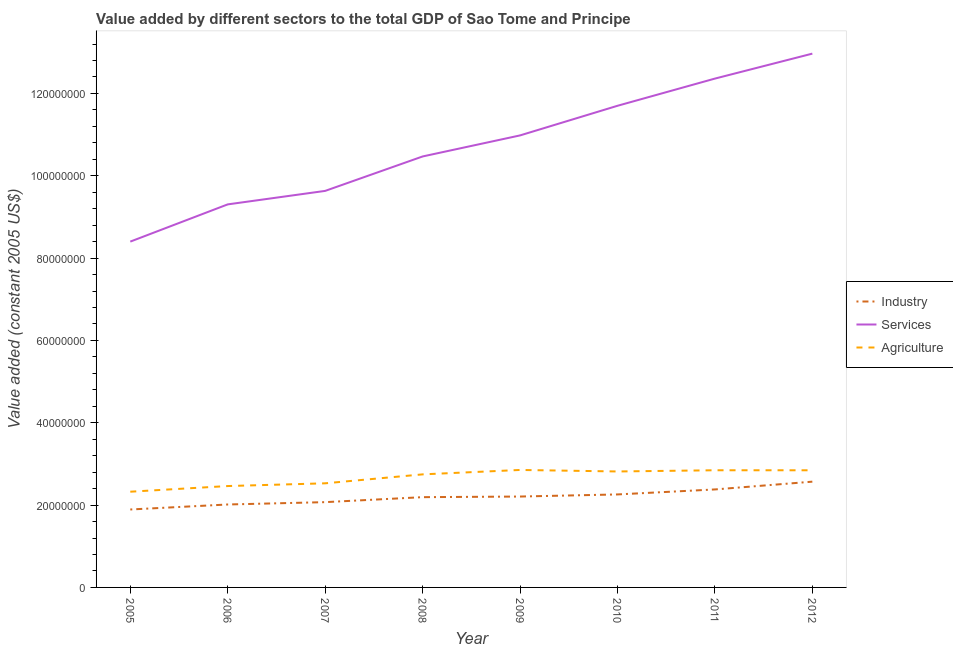How many different coloured lines are there?
Make the answer very short. 3. What is the value added by industrial sector in 2006?
Give a very brief answer. 2.01e+07. Across all years, what is the maximum value added by services?
Give a very brief answer. 1.30e+08. Across all years, what is the minimum value added by industrial sector?
Offer a terse response. 1.89e+07. In which year was the value added by services minimum?
Offer a terse response. 2005. What is the total value added by services in the graph?
Your answer should be compact. 8.58e+08. What is the difference between the value added by services in 2010 and that in 2012?
Give a very brief answer. -1.27e+07. What is the difference between the value added by services in 2012 and the value added by agricultural sector in 2006?
Offer a terse response. 1.05e+08. What is the average value added by agricultural sector per year?
Your response must be concise. 2.68e+07. In the year 2012, what is the difference between the value added by services and value added by industrial sector?
Your response must be concise. 1.04e+08. In how many years, is the value added by industrial sector greater than 24000000 US$?
Your answer should be very brief. 1. What is the ratio of the value added by industrial sector in 2005 to that in 2006?
Ensure brevity in your answer.  0.94. Is the value added by agricultural sector in 2009 less than that in 2011?
Provide a succinct answer. No. Is the difference between the value added by industrial sector in 2005 and 2010 greater than the difference between the value added by services in 2005 and 2010?
Ensure brevity in your answer.  Yes. What is the difference between the highest and the second highest value added by agricultural sector?
Provide a succinct answer. 7.39e+04. What is the difference between the highest and the lowest value added by agricultural sector?
Your answer should be compact. 5.28e+06. In how many years, is the value added by agricultural sector greater than the average value added by agricultural sector taken over all years?
Keep it short and to the point. 5. Does the value added by agricultural sector monotonically increase over the years?
Make the answer very short. No. Is the value added by industrial sector strictly greater than the value added by services over the years?
Your answer should be compact. No. How many lines are there?
Make the answer very short. 3. How many years are there in the graph?
Your response must be concise. 8. What is the difference between two consecutive major ticks on the Y-axis?
Keep it short and to the point. 2.00e+07. Are the values on the major ticks of Y-axis written in scientific E-notation?
Keep it short and to the point. No. Does the graph contain any zero values?
Make the answer very short. No. Where does the legend appear in the graph?
Provide a succinct answer. Center right. What is the title of the graph?
Offer a terse response. Value added by different sectors to the total GDP of Sao Tome and Principe. What is the label or title of the Y-axis?
Give a very brief answer. Value added (constant 2005 US$). What is the Value added (constant 2005 US$) of Industry in 2005?
Provide a short and direct response. 1.89e+07. What is the Value added (constant 2005 US$) of Services in 2005?
Offer a terse response. 8.40e+07. What is the Value added (constant 2005 US$) in Agriculture in 2005?
Give a very brief answer. 2.33e+07. What is the Value added (constant 2005 US$) in Industry in 2006?
Offer a terse response. 2.01e+07. What is the Value added (constant 2005 US$) in Services in 2006?
Your answer should be very brief. 9.31e+07. What is the Value added (constant 2005 US$) in Agriculture in 2006?
Offer a very short reply. 2.46e+07. What is the Value added (constant 2005 US$) of Industry in 2007?
Offer a terse response. 2.07e+07. What is the Value added (constant 2005 US$) in Services in 2007?
Provide a succinct answer. 9.63e+07. What is the Value added (constant 2005 US$) in Agriculture in 2007?
Ensure brevity in your answer.  2.53e+07. What is the Value added (constant 2005 US$) in Industry in 2008?
Give a very brief answer. 2.19e+07. What is the Value added (constant 2005 US$) in Services in 2008?
Offer a terse response. 1.05e+08. What is the Value added (constant 2005 US$) in Agriculture in 2008?
Offer a terse response. 2.75e+07. What is the Value added (constant 2005 US$) in Industry in 2009?
Your response must be concise. 2.21e+07. What is the Value added (constant 2005 US$) in Services in 2009?
Give a very brief answer. 1.10e+08. What is the Value added (constant 2005 US$) of Agriculture in 2009?
Offer a very short reply. 2.85e+07. What is the Value added (constant 2005 US$) in Industry in 2010?
Your answer should be compact. 2.26e+07. What is the Value added (constant 2005 US$) in Services in 2010?
Give a very brief answer. 1.17e+08. What is the Value added (constant 2005 US$) of Agriculture in 2010?
Provide a short and direct response. 2.82e+07. What is the Value added (constant 2005 US$) in Industry in 2011?
Keep it short and to the point. 2.38e+07. What is the Value added (constant 2005 US$) of Services in 2011?
Make the answer very short. 1.24e+08. What is the Value added (constant 2005 US$) of Agriculture in 2011?
Your answer should be very brief. 2.85e+07. What is the Value added (constant 2005 US$) in Industry in 2012?
Make the answer very short. 2.57e+07. What is the Value added (constant 2005 US$) of Services in 2012?
Your answer should be very brief. 1.30e+08. What is the Value added (constant 2005 US$) in Agriculture in 2012?
Your response must be concise. 2.85e+07. Across all years, what is the maximum Value added (constant 2005 US$) in Industry?
Offer a very short reply. 2.57e+07. Across all years, what is the maximum Value added (constant 2005 US$) of Services?
Keep it short and to the point. 1.30e+08. Across all years, what is the maximum Value added (constant 2005 US$) of Agriculture?
Ensure brevity in your answer.  2.85e+07. Across all years, what is the minimum Value added (constant 2005 US$) of Industry?
Provide a short and direct response. 1.89e+07. Across all years, what is the minimum Value added (constant 2005 US$) of Services?
Your answer should be very brief. 8.40e+07. Across all years, what is the minimum Value added (constant 2005 US$) of Agriculture?
Provide a short and direct response. 2.33e+07. What is the total Value added (constant 2005 US$) of Industry in the graph?
Make the answer very short. 1.76e+08. What is the total Value added (constant 2005 US$) in Services in the graph?
Your answer should be very brief. 8.58e+08. What is the total Value added (constant 2005 US$) of Agriculture in the graph?
Offer a very short reply. 2.14e+08. What is the difference between the Value added (constant 2005 US$) of Industry in 2005 and that in 2006?
Provide a succinct answer. -1.22e+06. What is the difference between the Value added (constant 2005 US$) of Services in 2005 and that in 2006?
Ensure brevity in your answer.  -9.04e+06. What is the difference between the Value added (constant 2005 US$) in Agriculture in 2005 and that in 2006?
Provide a succinct answer. -1.38e+06. What is the difference between the Value added (constant 2005 US$) in Industry in 2005 and that in 2007?
Your answer should be very brief. -1.78e+06. What is the difference between the Value added (constant 2005 US$) of Services in 2005 and that in 2007?
Offer a terse response. -1.23e+07. What is the difference between the Value added (constant 2005 US$) in Agriculture in 2005 and that in 2007?
Provide a succinct answer. -2.04e+06. What is the difference between the Value added (constant 2005 US$) in Industry in 2005 and that in 2008?
Offer a very short reply. -2.99e+06. What is the difference between the Value added (constant 2005 US$) in Services in 2005 and that in 2008?
Your response must be concise. -2.07e+07. What is the difference between the Value added (constant 2005 US$) of Agriculture in 2005 and that in 2008?
Your response must be concise. -4.21e+06. What is the difference between the Value added (constant 2005 US$) in Industry in 2005 and that in 2009?
Offer a very short reply. -3.15e+06. What is the difference between the Value added (constant 2005 US$) of Services in 2005 and that in 2009?
Ensure brevity in your answer.  -2.58e+07. What is the difference between the Value added (constant 2005 US$) of Agriculture in 2005 and that in 2009?
Your answer should be compact. -5.28e+06. What is the difference between the Value added (constant 2005 US$) in Industry in 2005 and that in 2010?
Offer a terse response. -3.66e+06. What is the difference between the Value added (constant 2005 US$) of Services in 2005 and that in 2010?
Ensure brevity in your answer.  -3.30e+07. What is the difference between the Value added (constant 2005 US$) in Agriculture in 2005 and that in 2010?
Keep it short and to the point. -4.92e+06. What is the difference between the Value added (constant 2005 US$) of Industry in 2005 and that in 2011?
Keep it short and to the point. -4.87e+06. What is the difference between the Value added (constant 2005 US$) of Services in 2005 and that in 2011?
Ensure brevity in your answer.  -3.96e+07. What is the difference between the Value added (constant 2005 US$) in Agriculture in 2005 and that in 2011?
Make the answer very short. -5.21e+06. What is the difference between the Value added (constant 2005 US$) in Industry in 2005 and that in 2012?
Ensure brevity in your answer.  -6.76e+06. What is the difference between the Value added (constant 2005 US$) in Services in 2005 and that in 2012?
Give a very brief answer. -4.57e+07. What is the difference between the Value added (constant 2005 US$) of Agriculture in 2005 and that in 2012?
Make the answer very short. -5.20e+06. What is the difference between the Value added (constant 2005 US$) in Industry in 2006 and that in 2007?
Your answer should be very brief. -5.69e+05. What is the difference between the Value added (constant 2005 US$) of Services in 2006 and that in 2007?
Offer a terse response. -3.28e+06. What is the difference between the Value added (constant 2005 US$) in Agriculture in 2006 and that in 2007?
Offer a very short reply. -6.63e+05. What is the difference between the Value added (constant 2005 US$) of Industry in 2006 and that in 2008?
Offer a terse response. -1.78e+06. What is the difference between the Value added (constant 2005 US$) of Services in 2006 and that in 2008?
Provide a short and direct response. -1.16e+07. What is the difference between the Value added (constant 2005 US$) in Agriculture in 2006 and that in 2008?
Your response must be concise. -2.84e+06. What is the difference between the Value added (constant 2005 US$) of Industry in 2006 and that in 2009?
Provide a short and direct response. -1.93e+06. What is the difference between the Value added (constant 2005 US$) of Services in 2006 and that in 2009?
Make the answer very short. -1.68e+07. What is the difference between the Value added (constant 2005 US$) of Agriculture in 2006 and that in 2009?
Provide a succinct answer. -3.91e+06. What is the difference between the Value added (constant 2005 US$) in Industry in 2006 and that in 2010?
Your answer should be very brief. -2.44e+06. What is the difference between the Value added (constant 2005 US$) in Services in 2006 and that in 2010?
Your answer should be compact. -2.40e+07. What is the difference between the Value added (constant 2005 US$) in Agriculture in 2006 and that in 2010?
Keep it short and to the point. -3.54e+06. What is the difference between the Value added (constant 2005 US$) in Industry in 2006 and that in 2011?
Your response must be concise. -3.65e+06. What is the difference between the Value added (constant 2005 US$) in Services in 2006 and that in 2011?
Your answer should be very brief. -3.06e+07. What is the difference between the Value added (constant 2005 US$) in Agriculture in 2006 and that in 2011?
Make the answer very short. -3.83e+06. What is the difference between the Value added (constant 2005 US$) of Industry in 2006 and that in 2012?
Your answer should be compact. -5.55e+06. What is the difference between the Value added (constant 2005 US$) of Services in 2006 and that in 2012?
Your answer should be very brief. -3.66e+07. What is the difference between the Value added (constant 2005 US$) in Agriculture in 2006 and that in 2012?
Your response must be concise. -3.83e+06. What is the difference between the Value added (constant 2005 US$) in Industry in 2007 and that in 2008?
Provide a succinct answer. -1.21e+06. What is the difference between the Value added (constant 2005 US$) in Services in 2007 and that in 2008?
Ensure brevity in your answer.  -8.36e+06. What is the difference between the Value added (constant 2005 US$) of Agriculture in 2007 and that in 2008?
Give a very brief answer. -2.17e+06. What is the difference between the Value added (constant 2005 US$) in Industry in 2007 and that in 2009?
Your answer should be compact. -1.36e+06. What is the difference between the Value added (constant 2005 US$) of Services in 2007 and that in 2009?
Keep it short and to the point. -1.35e+07. What is the difference between the Value added (constant 2005 US$) in Agriculture in 2007 and that in 2009?
Make the answer very short. -3.25e+06. What is the difference between the Value added (constant 2005 US$) of Industry in 2007 and that in 2010?
Your answer should be compact. -1.87e+06. What is the difference between the Value added (constant 2005 US$) of Services in 2007 and that in 2010?
Your response must be concise. -2.07e+07. What is the difference between the Value added (constant 2005 US$) in Agriculture in 2007 and that in 2010?
Give a very brief answer. -2.88e+06. What is the difference between the Value added (constant 2005 US$) of Industry in 2007 and that in 2011?
Your response must be concise. -3.09e+06. What is the difference between the Value added (constant 2005 US$) of Services in 2007 and that in 2011?
Provide a short and direct response. -2.73e+07. What is the difference between the Value added (constant 2005 US$) of Agriculture in 2007 and that in 2011?
Offer a very short reply. -3.17e+06. What is the difference between the Value added (constant 2005 US$) in Industry in 2007 and that in 2012?
Keep it short and to the point. -4.98e+06. What is the difference between the Value added (constant 2005 US$) in Services in 2007 and that in 2012?
Offer a terse response. -3.33e+07. What is the difference between the Value added (constant 2005 US$) in Agriculture in 2007 and that in 2012?
Provide a short and direct response. -3.17e+06. What is the difference between the Value added (constant 2005 US$) of Industry in 2008 and that in 2009?
Your answer should be very brief. -1.52e+05. What is the difference between the Value added (constant 2005 US$) in Services in 2008 and that in 2009?
Provide a succinct answer. -5.11e+06. What is the difference between the Value added (constant 2005 US$) in Agriculture in 2008 and that in 2009?
Your answer should be very brief. -1.07e+06. What is the difference between the Value added (constant 2005 US$) of Industry in 2008 and that in 2010?
Offer a very short reply. -6.63e+05. What is the difference between the Value added (constant 2005 US$) in Services in 2008 and that in 2010?
Your answer should be compact. -1.23e+07. What is the difference between the Value added (constant 2005 US$) of Agriculture in 2008 and that in 2010?
Offer a very short reply. -7.05e+05. What is the difference between the Value added (constant 2005 US$) of Industry in 2008 and that in 2011?
Keep it short and to the point. -1.88e+06. What is the difference between the Value added (constant 2005 US$) of Services in 2008 and that in 2011?
Offer a very short reply. -1.89e+07. What is the difference between the Value added (constant 2005 US$) in Agriculture in 2008 and that in 2011?
Ensure brevity in your answer.  -9.98e+05. What is the difference between the Value added (constant 2005 US$) of Industry in 2008 and that in 2012?
Offer a terse response. -3.77e+06. What is the difference between the Value added (constant 2005 US$) in Services in 2008 and that in 2012?
Your answer should be compact. -2.50e+07. What is the difference between the Value added (constant 2005 US$) of Agriculture in 2008 and that in 2012?
Provide a succinct answer. -9.93e+05. What is the difference between the Value added (constant 2005 US$) of Industry in 2009 and that in 2010?
Your answer should be very brief. -5.12e+05. What is the difference between the Value added (constant 2005 US$) in Services in 2009 and that in 2010?
Your response must be concise. -7.20e+06. What is the difference between the Value added (constant 2005 US$) of Agriculture in 2009 and that in 2010?
Your answer should be very brief. 3.67e+05. What is the difference between the Value added (constant 2005 US$) in Industry in 2009 and that in 2011?
Provide a short and direct response. -1.72e+06. What is the difference between the Value added (constant 2005 US$) in Services in 2009 and that in 2011?
Offer a terse response. -1.38e+07. What is the difference between the Value added (constant 2005 US$) in Agriculture in 2009 and that in 2011?
Your answer should be very brief. 7.39e+04. What is the difference between the Value added (constant 2005 US$) of Industry in 2009 and that in 2012?
Provide a succinct answer. -3.61e+06. What is the difference between the Value added (constant 2005 US$) of Services in 2009 and that in 2012?
Provide a short and direct response. -1.99e+07. What is the difference between the Value added (constant 2005 US$) in Agriculture in 2009 and that in 2012?
Your answer should be compact. 7.86e+04. What is the difference between the Value added (constant 2005 US$) of Industry in 2010 and that in 2011?
Provide a succinct answer. -1.21e+06. What is the difference between the Value added (constant 2005 US$) of Services in 2010 and that in 2011?
Your answer should be very brief. -6.61e+06. What is the difference between the Value added (constant 2005 US$) in Agriculture in 2010 and that in 2011?
Your response must be concise. -2.93e+05. What is the difference between the Value added (constant 2005 US$) of Industry in 2010 and that in 2012?
Offer a terse response. -3.10e+06. What is the difference between the Value added (constant 2005 US$) in Services in 2010 and that in 2012?
Ensure brevity in your answer.  -1.27e+07. What is the difference between the Value added (constant 2005 US$) in Agriculture in 2010 and that in 2012?
Your response must be concise. -2.89e+05. What is the difference between the Value added (constant 2005 US$) in Industry in 2011 and that in 2012?
Provide a short and direct response. -1.89e+06. What is the difference between the Value added (constant 2005 US$) in Services in 2011 and that in 2012?
Provide a succinct answer. -6.07e+06. What is the difference between the Value added (constant 2005 US$) of Agriculture in 2011 and that in 2012?
Your response must be concise. 4665.81. What is the difference between the Value added (constant 2005 US$) in Industry in 2005 and the Value added (constant 2005 US$) in Services in 2006?
Your response must be concise. -7.41e+07. What is the difference between the Value added (constant 2005 US$) of Industry in 2005 and the Value added (constant 2005 US$) of Agriculture in 2006?
Keep it short and to the point. -5.70e+06. What is the difference between the Value added (constant 2005 US$) in Services in 2005 and the Value added (constant 2005 US$) in Agriculture in 2006?
Provide a succinct answer. 5.94e+07. What is the difference between the Value added (constant 2005 US$) of Industry in 2005 and the Value added (constant 2005 US$) of Services in 2007?
Offer a terse response. -7.74e+07. What is the difference between the Value added (constant 2005 US$) in Industry in 2005 and the Value added (constant 2005 US$) in Agriculture in 2007?
Offer a very short reply. -6.36e+06. What is the difference between the Value added (constant 2005 US$) in Services in 2005 and the Value added (constant 2005 US$) in Agriculture in 2007?
Ensure brevity in your answer.  5.87e+07. What is the difference between the Value added (constant 2005 US$) of Industry in 2005 and the Value added (constant 2005 US$) of Services in 2008?
Keep it short and to the point. -8.58e+07. What is the difference between the Value added (constant 2005 US$) of Industry in 2005 and the Value added (constant 2005 US$) of Agriculture in 2008?
Offer a terse response. -8.53e+06. What is the difference between the Value added (constant 2005 US$) of Services in 2005 and the Value added (constant 2005 US$) of Agriculture in 2008?
Give a very brief answer. 5.65e+07. What is the difference between the Value added (constant 2005 US$) in Industry in 2005 and the Value added (constant 2005 US$) in Services in 2009?
Your answer should be very brief. -9.09e+07. What is the difference between the Value added (constant 2005 US$) in Industry in 2005 and the Value added (constant 2005 US$) in Agriculture in 2009?
Provide a short and direct response. -9.60e+06. What is the difference between the Value added (constant 2005 US$) in Services in 2005 and the Value added (constant 2005 US$) in Agriculture in 2009?
Provide a succinct answer. 5.55e+07. What is the difference between the Value added (constant 2005 US$) in Industry in 2005 and the Value added (constant 2005 US$) in Services in 2010?
Ensure brevity in your answer.  -9.81e+07. What is the difference between the Value added (constant 2005 US$) of Industry in 2005 and the Value added (constant 2005 US$) of Agriculture in 2010?
Your answer should be very brief. -9.24e+06. What is the difference between the Value added (constant 2005 US$) in Services in 2005 and the Value added (constant 2005 US$) in Agriculture in 2010?
Your answer should be compact. 5.58e+07. What is the difference between the Value added (constant 2005 US$) in Industry in 2005 and the Value added (constant 2005 US$) in Services in 2011?
Keep it short and to the point. -1.05e+08. What is the difference between the Value added (constant 2005 US$) in Industry in 2005 and the Value added (constant 2005 US$) in Agriculture in 2011?
Give a very brief answer. -9.53e+06. What is the difference between the Value added (constant 2005 US$) of Services in 2005 and the Value added (constant 2005 US$) of Agriculture in 2011?
Your response must be concise. 5.55e+07. What is the difference between the Value added (constant 2005 US$) of Industry in 2005 and the Value added (constant 2005 US$) of Services in 2012?
Give a very brief answer. -1.11e+08. What is the difference between the Value added (constant 2005 US$) of Industry in 2005 and the Value added (constant 2005 US$) of Agriculture in 2012?
Your answer should be compact. -9.53e+06. What is the difference between the Value added (constant 2005 US$) in Services in 2005 and the Value added (constant 2005 US$) in Agriculture in 2012?
Your answer should be very brief. 5.55e+07. What is the difference between the Value added (constant 2005 US$) of Industry in 2006 and the Value added (constant 2005 US$) of Services in 2007?
Give a very brief answer. -7.62e+07. What is the difference between the Value added (constant 2005 US$) in Industry in 2006 and the Value added (constant 2005 US$) in Agriculture in 2007?
Make the answer very short. -5.14e+06. What is the difference between the Value added (constant 2005 US$) in Services in 2006 and the Value added (constant 2005 US$) in Agriculture in 2007?
Give a very brief answer. 6.78e+07. What is the difference between the Value added (constant 2005 US$) of Industry in 2006 and the Value added (constant 2005 US$) of Services in 2008?
Your response must be concise. -8.45e+07. What is the difference between the Value added (constant 2005 US$) of Industry in 2006 and the Value added (constant 2005 US$) of Agriculture in 2008?
Your answer should be very brief. -7.32e+06. What is the difference between the Value added (constant 2005 US$) of Services in 2006 and the Value added (constant 2005 US$) of Agriculture in 2008?
Provide a short and direct response. 6.56e+07. What is the difference between the Value added (constant 2005 US$) in Industry in 2006 and the Value added (constant 2005 US$) in Services in 2009?
Your response must be concise. -8.97e+07. What is the difference between the Value added (constant 2005 US$) in Industry in 2006 and the Value added (constant 2005 US$) in Agriculture in 2009?
Give a very brief answer. -8.39e+06. What is the difference between the Value added (constant 2005 US$) of Services in 2006 and the Value added (constant 2005 US$) of Agriculture in 2009?
Your answer should be compact. 6.45e+07. What is the difference between the Value added (constant 2005 US$) of Industry in 2006 and the Value added (constant 2005 US$) of Services in 2010?
Provide a succinct answer. -9.69e+07. What is the difference between the Value added (constant 2005 US$) in Industry in 2006 and the Value added (constant 2005 US$) in Agriculture in 2010?
Your answer should be compact. -8.02e+06. What is the difference between the Value added (constant 2005 US$) in Services in 2006 and the Value added (constant 2005 US$) in Agriculture in 2010?
Your answer should be compact. 6.49e+07. What is the difference between the Value added (constant 2005 US$) in Industry in 2006 and the Value added (constant 2005 US$) in Services in 2011?
Offer a very short reply. -1.03e+08. What is the difference between the Value added (constant 2005 US$) in Industry in 2006 and the Value added (constant 2005 US$) in Agriculture in 2011?
Keep it short and to the point. -8.31e+06. What is the difference between the Value added (constant 2005 US$) in Services in 2006 and the Value added (constant 2005 US$) in Agriculture in 2011?
Make the answer very short. 6.46e+07. What is the difference between the Value added (constant 2005 US$) of Industry in 2006 and the Value added (constant 2005 US$) of Services in 2012?
Make the answer very short. -1.10e+08. What is the difference between the Value added (constant 2005 US$) of Industry in 2006 and the Value added (constant 2005 US$) of Agriculture in 2012?
Offer a terse response. -8.31e+06. What is the difference between the Value added (constant 2005 US$) in Services in 2006 and the Value added (constant 2005 US$) in Agriculture in 2012?
Offer a terse response. 6.46e+07. What is the difference between the Value added (constant 2005 US$) in Industry in 2007 and the Value added (constant 2005 US$) in Services in 2008?
Provide a short and direct response. -8.40e+07. What is the difference between the Value added (constant 2005 US$) of Industry in 2007 and the Value added (constant 2005 US$) of Agriculture in 2008?
Your response must be concise. -6.75e+06. What is the difference between the Value added (constant 2005 US$) of Services in 2007 and the Value added (constant 2005 US$) of Agriculture in 2008?
Give a very brief answer. 6.89e+07. What is the difference between the Value added (constant 2005 US$) of Industry in 2007 and the Value added (constant 2005 US$) of Services in 2009?
Keep it short and to the point. -8.91e+07. What is the difference between the Value added (constant 2005 US$) in Industry in 2007 and the Value added (constant 2005 US$) in Agriculture in 2009?
Your answer should be compact. -7.82e+06. What is the difference between the Value added (constant 2005 US$) in Services in 2007 and the Value added (constant 2005 US$) in Agriculture in 2009?
Your answer should be very brief. 6.78e+07. What is the difference between the Value added (constant 2005 US$) in Industry in 2007 and the Value added (constant 2005 US$) in Services in 2010?
Your answer should be very brief. -9.63e+07. What is the difference between the Value added (constant 2005 US$) of Industry in 2007 and the Value added (constant 2005 US$) of Agriculture in 2010?
Provide a succinct answer. -7.45e+06. What is the difference between the Value added (constant 2005 US$) in Services in 2007 and the Value added (constant 2005 US$) in Agriculture in 2010?
Your response must be concise. 6.82e+07. What is the difference between the Value added (constant 2005 US$) in Industry in 2007 and the Value added (constant 2005 US$) in Services in 2011?
Provide a short and direct response. -1.03e+08. What is the difference between the Value added (constant 2005 US$) of Industry in 2007 and the Value added (constant 2005 US$) of Agriculture in 2011?
Make the answer very short. -7.75e+06. What is the difference between the Value added (constant 2005 US$) in Services in 2007 and the Value added (constant 2005 US$) in Agriculture in 2011?
Offer a very short reply. 6.79e+07. What is the difference between the Value added (constant 2005 US$) in Industry in 2007 and the Value added (constant 2005 US$) in Services in 2012?
Offer a terse response. -1.09e+08. What is the difference between the Value added (constant 2005 US$) in Industry in 2007 and the Value added (constant 2005 US$) in Agriculture in 2012?
Keep it short and to the point. -7.74e+06. What is the difference between the Value added (constant 2005 US$) in Services in 2007 and the Value added (constant 2005 US$) in Agriculture in 2012?
Your answer should be very brief. 6.79e+07. What is the difference between the Value added (constant 2005 US$) of Industry in 2008 and the Value added (constant 2005 US$) of Services in 2009?
Offer a very short reply. -8.79e+07. What is the difference between the Value added (constant 2005 US$) in Industry in 2008 and the Value added (constant 2005 US$) in Agriculture in 2009?
Your answer should be very brief. -6.61e+06. What is the difference between the Value added (constant 2005 US$) of Services in 2008 and the Value added (constant 2005 US$) of Agriculture in 2009?
Your response must be concise. 7.62e+07. What is the difference between the Value added (constant 2005 US$) of Industry in 2008 and the Value added (constant 2005 US$) of Services in 2010?
Your answer should be compact. -9.51e+07. What is the difference between the Value added (constant 2005 US$) in Industry in 2008 and the Value added (constant 2005 US$) in Agriculture in 2010?
Keep it short and to the point. -6.24e+06. What is the difference between the Value added (constant 2005 US$) of Services in 2008 and the Value added (constant 2005 US$) of Agriculture in 2010?
Offer a terse response. 7.65e+07. What is the difference between the Value added (constant 2005 US$) in Industry in 2008 and the Value added (constant 2005 US$) in Services in 2011?
Make the answer very short. -1.02e+08. What is the difference between the Value added (constant 2005 US$) in Industry in 2008 and the Value added (constant 2005 US$) in Agriculture in 2011?
Your response must be concise. -6.54e+06. What is the difference between the Value added (constant 2005 US$) of Services in 2008 and the Value added (constant 2005 US$) of Agriculture in 2011?
Your answer should be compact. 7.62e+07. What is the difference between the Value added (constant 2005 US$) of Industry in 2008 and the Value added (constant 2005 US$) of Services in 2012?
Provide a succinct answer. -1.08e+08. What is the difference between the Value added (constant 2005 US$) in Industry in 2008 and the Value added (constant 2005 US$) in Agriculture in 2012?
Make the answer very short. -6.53e+06. What is the difference between the Value added (constant 2005 US$) of Services in 2008 and the Value added (constant 2005 US$) of Agriculture in 2012?
Your answer should be very brief. 7.62e+07. What is the difference between the Value added (constant 2005 US$) of Industry in 2009 and the Value added (constant 2005 US$) of Services in 2010?
Offer a terse response. -9.49e+07. What is the difference between the Value added (constant 2005 US$) in Industry in 2009 and the Value added (constant 2005 US$) in Agriculture in 2010?
Make the answer very short. -6.09e+06. What is the difference between the Value added (constant 2005 US$) in Services in 2009 and the Value added (constant 2005 US$) in Agriculture in 2010?
Ensure brevity in your answer.  8.16e+07. What is the difference between the Value added (constant 2005 US$) in Industry in 2009 and the Value added (constant 2005 US$) in Services in 2011?
Your answer should be compact. -1.02e+08. What is the difference between the Value added (constant 2005 US$) of Industry in 2009 and the Value added (constant 2005 US$) of Agriculture in 2011?
Offer a very short reply. -6.38e+06. What is the difference between the Value added (constant 2005 US$) in Services in 2009 and the Value added (constant 2005 US$) in Agriculture in 2011?
Offer a very short reply. 8.13e+07. What is the difference between the Value added (constant 2005 US$) in Industry in 2009 and the Value added (constant 2005 US$) in Services in 2012?
Provide a succinct answer. -1.08e+08. What is the difference between the Value added (constant 2005 US$) in Industry in 2009 and the Value added (constant 2005 US$) in Agriculture in 2012?
Keep it short and to the point. -6.38e+06. What is the difference between the Value added (constant 2005 US$) in Services in 2009 and the Value added (constant 2005 US$) in Agriculture in 2012?
Your response must be concise. 8.13e+07. What is the difference between the Value added (constant 2005 US$) in Industry in 2010 and the Value added (constant 2005 US$) in Services in 2011?
Give a very brief answer. -1.01e+08. What is the difference between the Value added (constant 2005 US$) in Industry in 2010 and the Value added (constant 2005 US$) in Agriculture in 2011?
Provide a succinct answer. -5.87e+06. What is the difference between the Value added (constant 2005 US$) in Services in 2010 and the Value added (constant 2005 US$) in Agriculture in 2011?
Offer a terse response. 8.85e+07. What is the difference between the Value added (constant 2005 US$) in Industry in 2010 and the Value added (constant 2005 US$) in Services in 2012?
Provide a short and direct response. -1.07e+08. What is the difference between the Value added (constant 2005 US$) of Industry in 2010 and the Value added (constant 2005 US$) of Agriculture in 2012?
Make the answer very short. -5.87e+06. What is the difference between the Value added (constant 2005 US$) in Services in 2010 and the Value added (constant 2005 US$) in Agriculture in 2012?
Make the answer very short. 8.85e+07. What is the difference between the Value added (constant 2005 US$) of Industry in 2011 and the Value added (constant 2005 US$) of Services in 2012?
Your answer should be very brief. -1.06e+08. What is the difference between the Value added (constant 2005 US$) in Industry in 2011 and the Value added (constant 2005 US$) in Agriculture in 2012?
Give a very brief answer. -4.66e+06. What is the difference between the Value added (constant 2005 US$) in Services in 2011 and the Value added (constant 2005 US$) in Agriculture in 2012?
Your answer should be compact. 9.52e+07. What is the average Value added (constant 2005 US$) of Industry per year?
Ensure brevity in your answer.  2.20e+07. What is the average Value added (constant 2005 US$) in Services per year?
Provide a short and direct response. 1.07e+08. What is the average Value added (constant 2005 US$) of Agriculture per year?
Give a very brief answer. 2.68e+07. In the year 2005, what is the difference between the Value added (constant 2005 US$) in Industry and Value added (constant 2005 US$) in Services?
Your answer should be compact. -6.51e+07. In the year 2005, what is the difference between the Value added (constant 2005 US$) in Industry and Value added (constant 2005 US$) in Agriculture?
Ensure brevity in your answer.  -4.32e+06. In the year 2005, what is the difference between the Value added (constant 2005 US$) of Services and Value added (constant 2005 US$) of Agriculture?
Offer a very short reply. 6.08e+07. In the year 2006, what is the difference between the Value added (constant 2005 US$) of Industry and Value added (constant 2005 US$) of Services?
Ensure brevity in your answer.  -7.29e+07. In the year 2006, what is the difference between the Value added (constant 2005 US$) in Industry and Value added (constant 2005 US$) in Agriculture?
Provide a succinct answer. -4.48e+06. In the year 2006, what is the difference between the Value added (constant 2005 US$) of Services and Value added (constant 2005 US$) of Agriculture?
Your response must be concise. 6.84e+07. In the year 2007, what is the difference between the Value added (constant 2005 US$) of Industry and Value added (constant 2005 US$) of Services?
Ensure brevity in your answer.  -7.56e+07. In the year 2007, what is the difference between the Value added (constant 2005 US$) in Industry and Value added (constant 2005 US$) in Agriculture?
Keep it short and to the point. -4.57e+06. In the year 2007, what is the difference between the Value added (constant 2005 US$) in Services and Value added (constant 2005 US$) in Agriculture?
Make the answer very short. 7.10e+07. In the year 2008, what is the difference between the Value added (constant 2005 US$) in Industry and Value added (constant 2005 US$) in Services?
Give a very brief answer. -8.28e+07. In the year 2008, what is the difference between the Value added (constant 2005 US$) in Industry and Value added (constant 2005 US$) in Agriculture?
Provide a short and direct response. -5.54e+06. In the year 2008, what is the difference between the Value added (constant 2005 US$) in Services and Value added (constant 2005 US$) in Agriculture?
Your answer should be very brief. 7.72e+07. In the year 2009, what is the difference between the Value added (constant 2005 US$) of Industry and Value added (constant 2005 US$) of Services?
Offer a very short reply. -8.77e+07. In the year 2009, what is the difference between the Value added (constant 2005 US$) in Industry and Value added (constant 2005 US$) in Agriculture?
Make the answer very short. -6.46e+06. In the year 2009, what is the difference between the Value added (constant 2005 US$) of Services and Value added (constant 2005 US$) of Agriculture?
Your answer should be very brief. 8.13e+07. In the year 2010, what is the difference between the Value added (constant 2005 US$) in Industry and Value added (constant 2005 US$) in Services?
Offer a very short reply. -9.44e+07. In the year 2010, what is the difference between the Value added (constant 2005 US$) of Industry and Value added (constant 2005 US$) of Agriculture?
Ensure brevity in your answer.  -5.58e+06. In the year 2010, what is the difference between the Value added (constant 2005 US$) in Services and Value added (constant 2005 US$) in Agriculture?
Offer a very short reply. 8.88e+07. In the year 2011, what is the difference between the Value added (constant 2005 US$) in Industry and Value added (constant 2005 US$) in Services?
Your answer should be very brief. -9.98e+07. In the year 2011, what is the difference between the Value added (constant 2005 US$) in Industry and Value added (constant 2005 US$) in Agriculture?
Your answer should be very brief. -4.66e+06. In the year 2011, what is the difference between the Value added (constant 2005 US$) of Services and Value added (constant 2005 US$) of Agriculture?
Your response must be concise. 9.51e+07. In the year 2012, what is the difference between the Value added (constant 2005 US$) in Industry and Value added (constant 2005 US$) in Services?
Offer a very short reply. -1.04e+08. In the year 2012, what is the difference between the Value added (constant 2005 US$) in Industry and Value added (constant 2005 US$) in Agriculture?
Make the answer very short. -2.76e+06. In the year 2012, what is the difference between the Value added (constant 2005 US$) of Services and Value added (constant 2005 US$) of Agriculture?
Provide a short and direct response. 1.01e+08. What is the ratio of the Value added (constant 2005 US$) in Industry in 2005 to that in 2006?
Your answer should be compact. 0.94. What is the ratio of the Value added (constant 2005 US$) of Services in 2005 to that in 2006?
Provide a short and direct response. 0.9. What is the ratio of the Value added (constant 2005 US$) of Agriculture in 2005 to that in 2006?
Provide a succinct answer. 0.94. What is the ratio of the Value added (constant 2005 US$) of Industry in 2005 to that in 2007?
Your answer should be compact. 0.91. What is the ratio of the Value added (constant 2005 US$) in Services in 2005 to that in 2007?
Offer a very short reply. 0.87. What is the ratio of the Value added (constant 2005 US$) in Agriculture in 2005 to that in 2007?
Offer a terse response. 0.92. What is the ratio of the Value added (constant 2005 US$) in Industry in 2005 to that in 2008?
Your answer should be very brief. 0.86. What is the ratio of the Value added (constant 2005 US$) in Services in 2005 to that in 2008?
Give a very brief answer. 0.8. What is the ratio of the Value added (constant 2005 US$) in Agriculture in 2005 to that in 2008?
Keep it short and to the point. 0.85. What is the ratio of the Value added (constant 2005 US$) in Industry in 2005 to that in 2009?
Keep it short and to the point. 0.86. What is the ratio of the Value added (constant 2005 US$) in Services in 2005 to that in 2009?
Ensure brevity in your answer.  0.77. What is the ratio of the Value added (constant 2005 US$) of Agriculture in 2005 to that in 2009?
Your answer should be very brief. 0.81. What is the ratio of the Value added (constant 2005 US$) of Industry in 2005 to that in 2010?
Offer a terse response. 0.84. What is the ratio of the Value added (constant 2005 US$) in Services in 2005 to that in 2010?
Ensure brevity in your answer.  0.72. What is the ratio of the Value added (constant 2005 US$) in Agriculture in 2005 to that in 2010?
Provide a succinct answer. 0.83. What is the ratio of the Value added (constant 2005 US$) of Industry in 2005 to that in 2011?
Your response must be concise. 0.8. What is the ratio of the Value added (constant 2005 US$) in Services in 2005 to that in 2011?
Offer a terse response. 0.68. What is the ratio of the Value added (constant 2005 US$) of Agriculture in 2005 to that in 2011?
Make the answer very short. 0.82. What is the ratio of the Value added (constant 2005 US$) in Industry in 2005 to that in 2012?
Offer a terse response. 0.74. What is the ratio of the Value added (constant 2005 US$) of Services in 2005 to that in 2012?
Your answer should be compact. 0.65. What is the ratio of the Value added (constant 2005 US$) in Agriculture in 2005 to that in 2012?
Provide a succinct answer. 0.82. What is the ratio of the Value added (constant 2005 US$) in Industry in 2006 to that in 2007?
Your answer should be very brief. 0.97. What is the ratio of the Value added (constant 2005 US$) in Services in 2006 to that in 2007?
Offer a terse response. 0.97. What is the ratio of the Value added (constant 2005 US$) of Agriculture in 2006 to that in 2007?
Provide a short and direct response. 0.97. What is the ratio of the Value added (constant 2005 US$) in Industry in 2006 to that in 2008?
Offer a terse response. 0.92. What is the ratio of the Value added (constant 2005 US$) of Services in 2006 to that in 2008?
Make the answer very short. 0.89. What is the ratio of the Value added (constant 2005 US$) of Agriculture in 2006 to that in 2008?
Provide a succinct answer. 0.9. What is the ratio of the Value added (constant 2005 US$) in Industry in 2006 to that in 2009?
Your answer should be compact. 0.91. What is the ratio of the Value added (constant 2005 US$) in Services in 2006 to that in 2009?
Your response must be concise. 0.85. What is the ratio of the Value added (constant 2005 US$) in Agriculture in 2006 to that in 2009?
Your answer should be very brief. 0.86. What is the ratio of the Value added (constant 2005 US$) in Industry in 2006 to that in 2010?
Ensure brevity in your answer.  0.89. What is the ratio of the Value added (constant 2005 US$) of Services in 2006 to that in 2010?
Offer a very short reply. 0.8. What is the ratio of the Value added (constant 2005 US$) in Agriculture in 2006 to that in 2010?
Provide a succinct answer. 0.87. What is the ratio of the Value added (constant 2005 US$) in Industry in 2006 to that in 2011?
Offer a terse response. 0.85. What is the ratio of the Value added (constant 2005 US$) of Services in 2006 to that in 2011?
Keep it short and to the point. 0.75. What is the ratio of the Value added (constant 2005 US$) in Agriculture in 2006 to that in 2011?
Provide a succinct answer. 0.87. What is the ratio of the Value added (constant 2005 US$) in Industry in 2006 to that in 2012?
Give a very brief answer. 0.78. What is the ratio of the Value added (constant 2005 US$) of Services in 2006 to that in 2012?
Offer a very short reply. 0.72. What is the ratio of the Value added (constant 2005 US$) in Agriculture in 2006 to that in 2012?
Your response must be concise. 0.87. What is the ratio of the Value added (constant 2005 US$) in Industry in 2007 to that in 2008?
Provide a succinct answer. 0.94. What is the ratio of the Value added (constant 2005 US$) of Services in 2007 to that in 2008?
Your answer should be compact. 0.92. What is the ratio of the Value added (constant 2005 US$) in Agriculture in 2007 to that in 2008?
Ensure brevity in your answer.  0.92. What is the ratio of the Value added (constant 2005 US$) of Industry in 2007 to that in 2009?
Your answer should be compact. 0.94. What is the ratio of the Value added (constant 2005 US$) in Services in 2007 to that in 2009?
Provide a short and direct response. 0.88. What is the ratio of the Value added (constant 2005 US$) of Agriculture in 2007 to that in 2009?
Offer a terse response. 0.89. What is the ratio of the Value added (constant 2005 US$) of Industry in 2007 to that in 2010?
Provide a short and direct response. 0.92. What is the ratio of the Value added (constant 2005 US$) of Services in 2007 to that in 2010?
Offer a terse response. 0.82. What is the ratio of the Value added (constant 2005 US$) of Agriculture in 2007 to that in 2010?
Ensure brevity in your answer.  0.9. What is the ratio of the Value added (constant 2005 US$) in Industry in 2007 to that in 2011?
Ensure brevity in your answer.  0.87. What is the ratio of the Value added (constant 2005 US$) of Services in 2007 to that in 2011?
Your answer should be very brief. 0.78. What is the ratio of the Value added (constant 2005 US$) of Agriculture in 2007 to that in 2011?
Your response must be concise. 0.89. What is the ratio of the Value added (constant 2005 US$) in Industry in 2007 to that in 2012?
Keep it short and to the point. 0.81. What is the ratio of the Value added (constant 2005 US$) of Services in 2007 to that in 2012?
Your answer should be very brief. 0.74. What is the ratio of the Value added (constant 2005 US$) of Agriculture in 2007 to that in 2012?
Offer a terse response. 0.89. What is the ratio of the Value added (constant 2005 US$) of Services in 2008 to that in 2009?
Provide a succinct answer. 0.95. What is the ratio of the Value added (constant 2005 US$) of Agriculture in 2008 to that in 2009?
Provide a short and direct response. 0.96. What is the ratio of the Value added (constant 2005 US$) of Industry in 2008 to that in 2010?
Offer a very short reply. 0.97. What is the ratio of the Value added (constant 2005 US$) in Services in 2008 to that in 2010?
Your answer should be very brief. 0.89. What is the ratio of the Value added (constant 2005 US$) in Industry in 2008 to that in 2011?
Keep it short and to the point. 0.92. What is the ratio of the Value added (constant 2005 US$) of Services in 2008 to that in 2011?
Keep it short and to the point. 0.85. What is the ratio of the Value added (constant 2005 US$) in Agriculture in 2008 to that in 2011?
Ensure brevity in your answer.  0.96. What is the ratio of the Value added (constant 2005 US$) in Industry in 2008 to that in 2012?
Your response must be concise. 0.85. What is the ratio of the Value added (constant 2005 US$) of Services in 2008 to that in 2012?
Your response must be concise. 0.81. What is the ratio of the Value added (constant 2005 US$) in Agriculture in 2008 to that in 2012?
Your response must be concise. 0.97. What is the ratio of the Value added (constant 2005 US$) in Industry in 2009 to that in 2010?
Offer a terse response. 0.98. What is the ratio of the Value added (constant 2005 US$) in Services in 2009 to that in 2010?
Keep it short and to the point. 0.94. What is the ratio of the Value added (constant 2005 US$) of Industry in 2009 to that in 2011?
Keep it short and to the point. 0.93. What is the ratio of the Value added (constant 2005 US$) in Services in 2009 to that in 2011?
Keep it short and to the point. 0.89. What is the ratio of the Value added (constant 2005 US$) of Industry in 2009 to that in 2012?
Your answer should be very brief. 0.86. What is the ratio of the Value added (constant 2005 US$) of Services in 2009 to that in 2012?
Keep it short and to the point. 0.85. What is the ratio of the Value added (constant 2005 US$) of Industry in 2010 to that in 2011?
Ensure brevity in your answer.  0.95. What is the ratio of the Value added (constant 2005 US$) of Services in 2010 to that in 2011?
Your answer should be very brief. 0.95. What is the ratio of the Value added (constant 2005 US$) of Agriculture in 2010 to that in 2011?
Your answer should be very brief. 0.99. What is the ratio of the Value added (constant 2005 US$) of Industry in 2010 to that in 2012?
Ensure brevity in your answer.  0.88. What is the ratio of the Value added (constant 2005 US$) of Services in 2010 to that in 2012?
Make the answer very short. 0.9. What is the ratio of the Value added (constant 2005 US$) of Industry in 2011 to that in 2012?
Keep it short and to the point. 0.93. What is the ratio of the Value added (constant 2005 US$) of Services in 2011 to that in 2012?
Your answer should be very brief. 0.95. What is the ratio of the Value added (constant 2005 US$) of Agriculture in 2011 to that in 2012?
Offer a very short reply. 1. What is the difference between the highest and the second highest Value added (constant 2005 US$) of Industry?
Your response must be concise. 1.89e+06. What is the difference between the highest and the second highest Value added (constant 2005 US$) of Services?
Provide a short and direct response. 6.07e+06. What is the difference between the highest and the second highest Value added (constant 2005 US$) in Agriculture?
Your answer should be compact. 7.39e+04. What is the difference between the highest and the lowest Value added (constant 2005 US$) in Industry?
Make the answer very short. 6.76e+06. What is the difference between the highest and the lowest Value added (constant 2005 US$) of Services?
Ensure brevity in your answer.  4.57e+07. What is the difference between the highest and the lowest Value added (constant 2005 US$) of Agriculture?
Provide a succinct answer. 5.28e+06. 